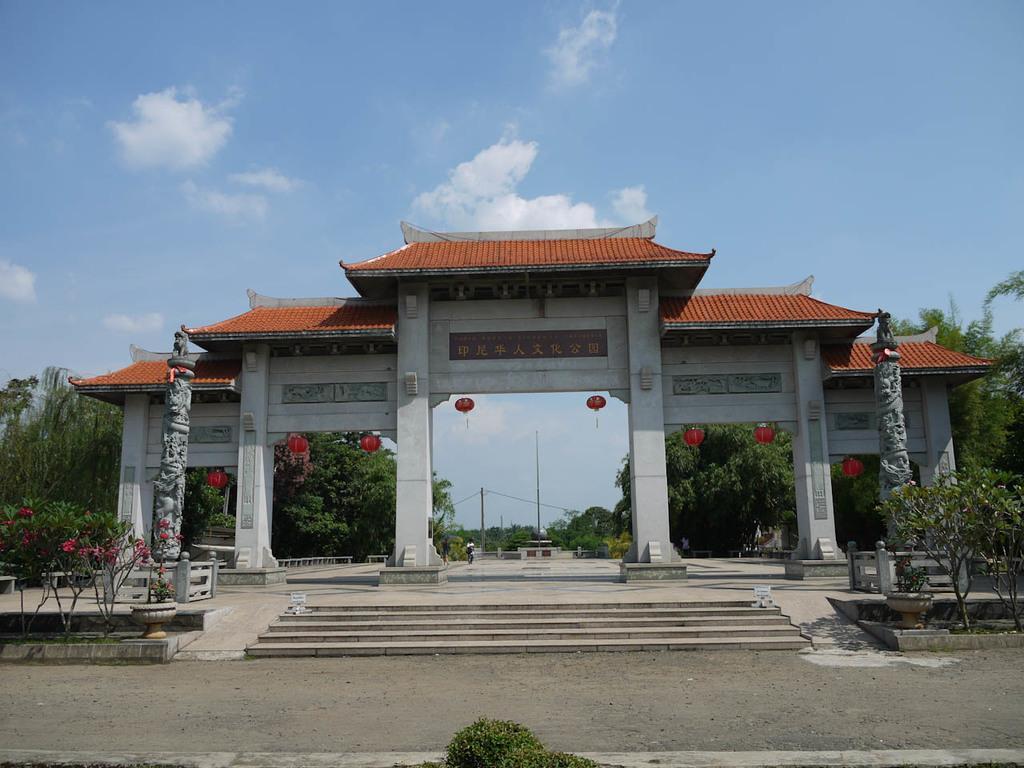In one or two sentences, can you explain what this image depicts? In this picture we can see the road, steps, pillars, lanterns, trees, poles and in the background we can see the sky with clouds. 